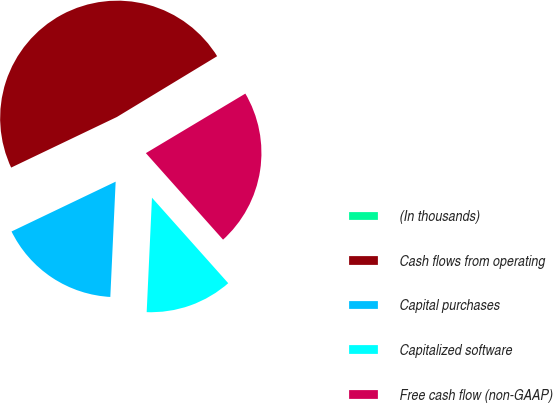Convert chart to OTSL. <chart><loc_0><loc_0><loc_500><loc_500><pie_chart><fcel>(In thousands)<fcel>Cash flows from operating<fcel>Capital purchases<fcel>Capitalized software<fcel>Free cash flow (non-GAAP)<nl><fcel>0.09%<fcel>48.43%<fcel>17.16%<fcel>12.33%<fcel>21.99%<nl></chart> 